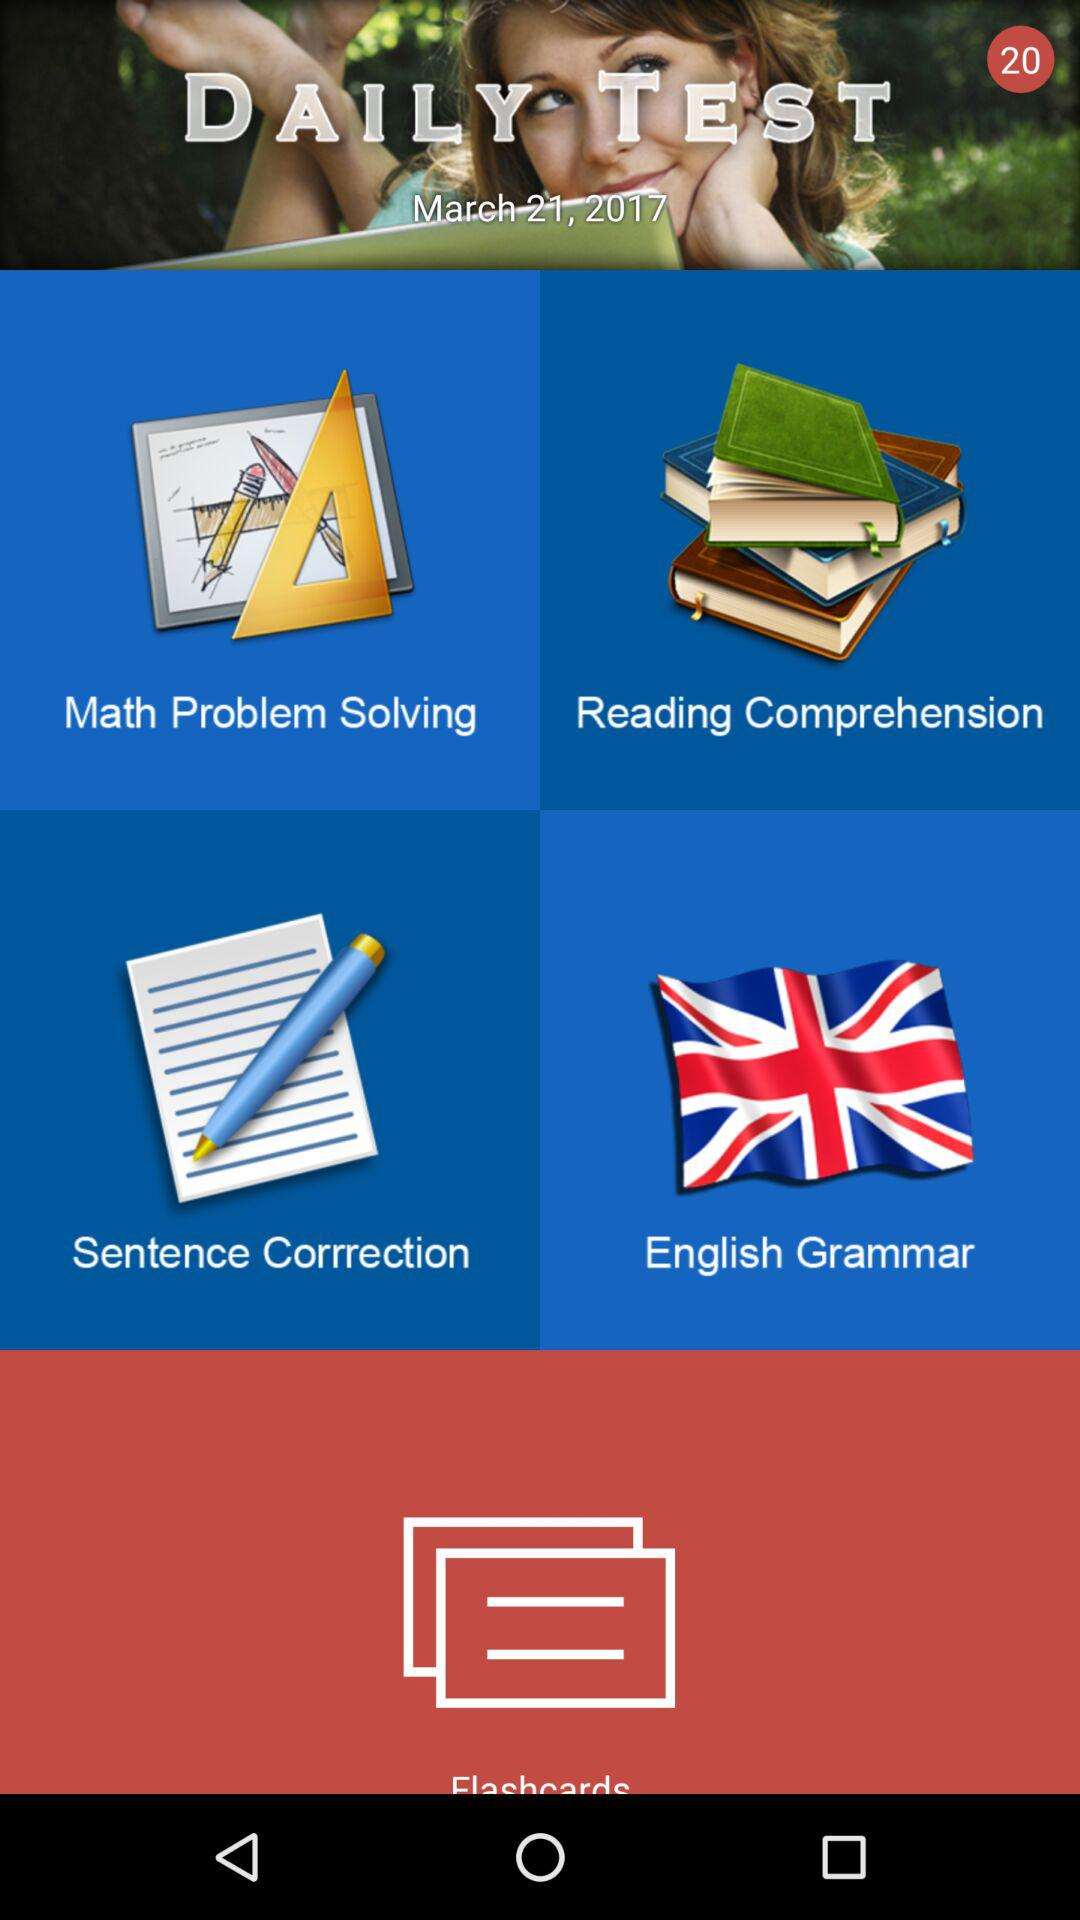What is the date? The date is March 21, 2017. 